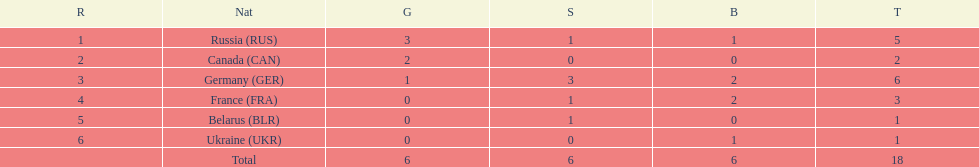Which country won the same amount of silver medals as the french and the russians? Belarus. 